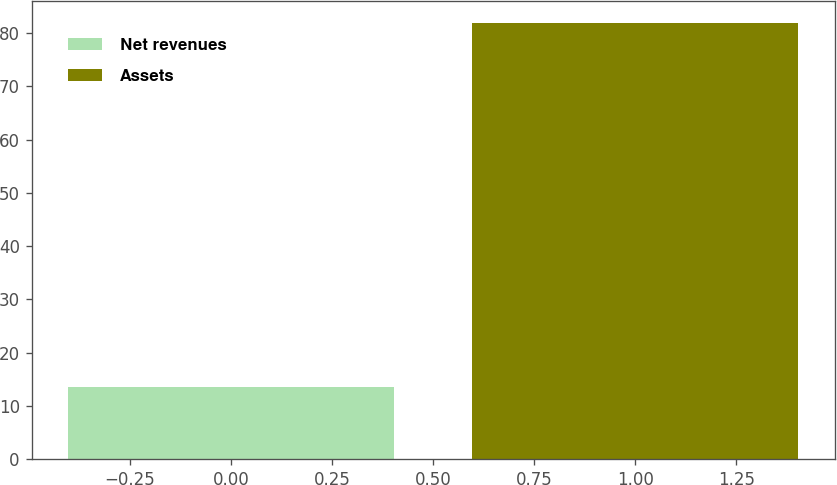Convert chart. <chart><loc_0><loc_0><loc_500><loc_500><bar_chart><fcel>Net revenues<fcel>Assets<nl><fcel>13.5<fcel>81.9<nl></chart> 